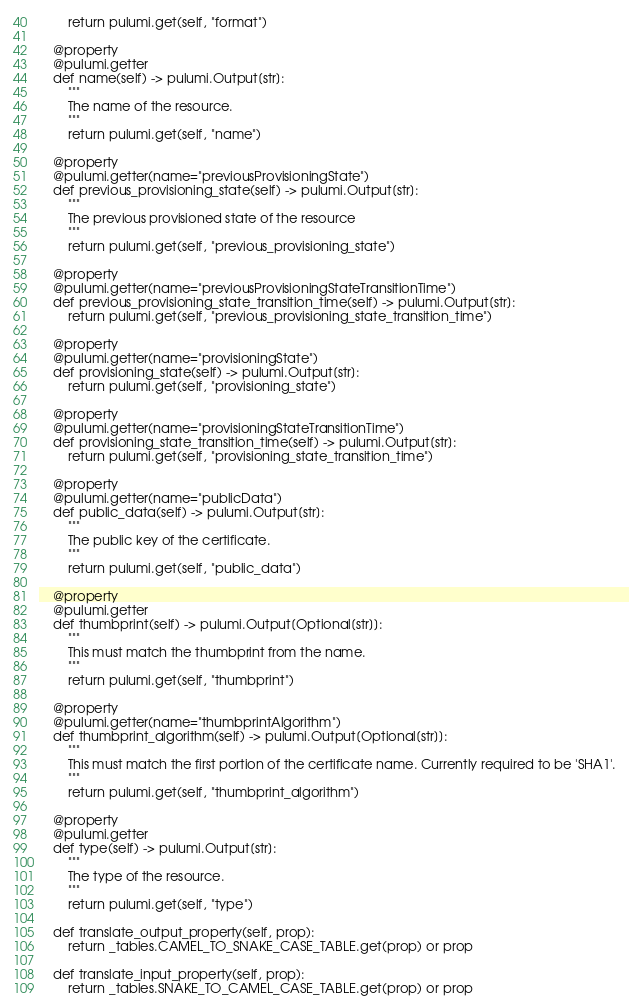Convert code to text. <code><loc_0><loc_0><loc_500><loc_500><_Python_>        return pulumi.get(self, "format")

    @property
    @pulumi.getter
    def name(self) -> pulumi.Output[str]:
        """
        The name of the resource.
        """
        return pulumi.get(self, "name")

    @property
    @pulumi.getter(name="previousProvisioningState")
    def previous_provisioning_state(self) -> pulumi.Output[str]:
        """
        The previous provisioned state of the resource
        """
        return pulumi.get(self, "previous_provisioning_state")

    @property
    @pulumi.getter(name="previousProvisioningStateTransitionTime")
    def previous_provisioning_state_transition_time(self) -> pulumi.Output[str]:
        return pulumi.get(self, "previous_provisioning_state_transition_time")

    @property
    @pulumi.getter(name="provisioningState")
    def provisioning_state(self) -> pulumi.Output[str]:
        return pulumi.get(self, "provisioning_state")

    @property
    @pulumi.getter(name="provisioningStateTransitionTime")
    def provisioning_state_transition_time(self) -> pulumi.Output[str]:
        return pulumi.get(self, "provisioning_state_transition_time")

    @property
    @pulumi.getter(name="publicData")
    def public_data(self) -> pulumi.Output[str]:
        """
        The public key of the certificate.
        """
        return pulumi.get(self, "public_data")

    @property
    @pulumi.getter
    def thumbprint(self) -> pulumi.Output[Optional[str]]:
        """
        This must match the thumbprint from the name.
        """
        return pulumi.get(self, "thumbprint")

    @property
    @pulumi.getter(name="thumbprintAlgorithm")
    def thumbprint_algorithm(self) -> pulumi.Output[Optional[str]]:
        """
        This must match the first portion of the certificate name. Currently required to be 'SHA1'.
        """
        return pulumi.get(self, "thumbprint_algorithm")

    @property
    @pulumi.getter
    def type(self) -> pulumi.Output[str]:
        """
        The type of the resource.
        """
        return pulumi.get(self, "type")

    def translate_output_property(self, prop):
        return _tables.CAMEL_TO_SNAKE_CASE_TABLE.get(prop) or prop

    def translate_input_property(self, prop):
        return _tables.SNAKE_TO_CAMEL_CASE_TABLE.get(prop) or prop

</code> 